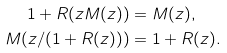Convert formula to latex. <formula><loc_0><loc_0><loc_500><loc_500>1 + R ( z M ( z ) ) & = M ( z ) , \\ M ( z / ( 1 + R ( z ) ) ) & = 1 + R ( z ) .</formula> 